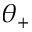<formula> <loc_0><loc_0><loc_500><loc_500>\theta _ { + }</formula> 